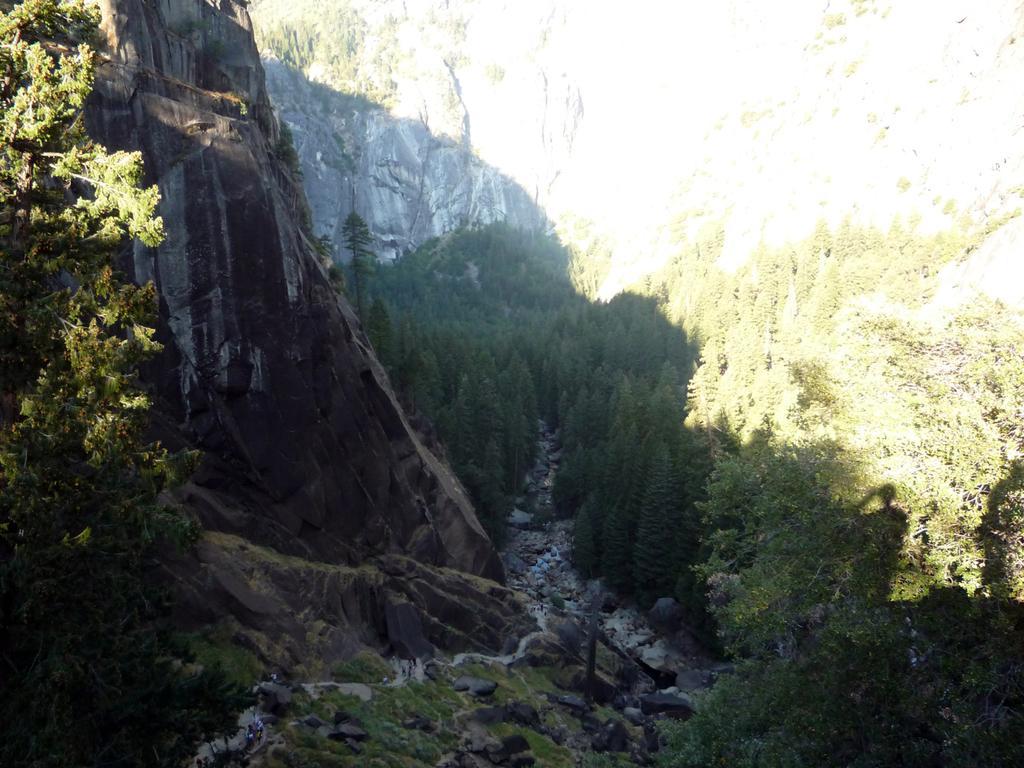In one or two sentences, can you explain what this image depicts? This picture is clicked outside. In the foreground we can see the green grass, plants, trees and the rocks and some other objects. In the background we can see the trees and the rocks. 